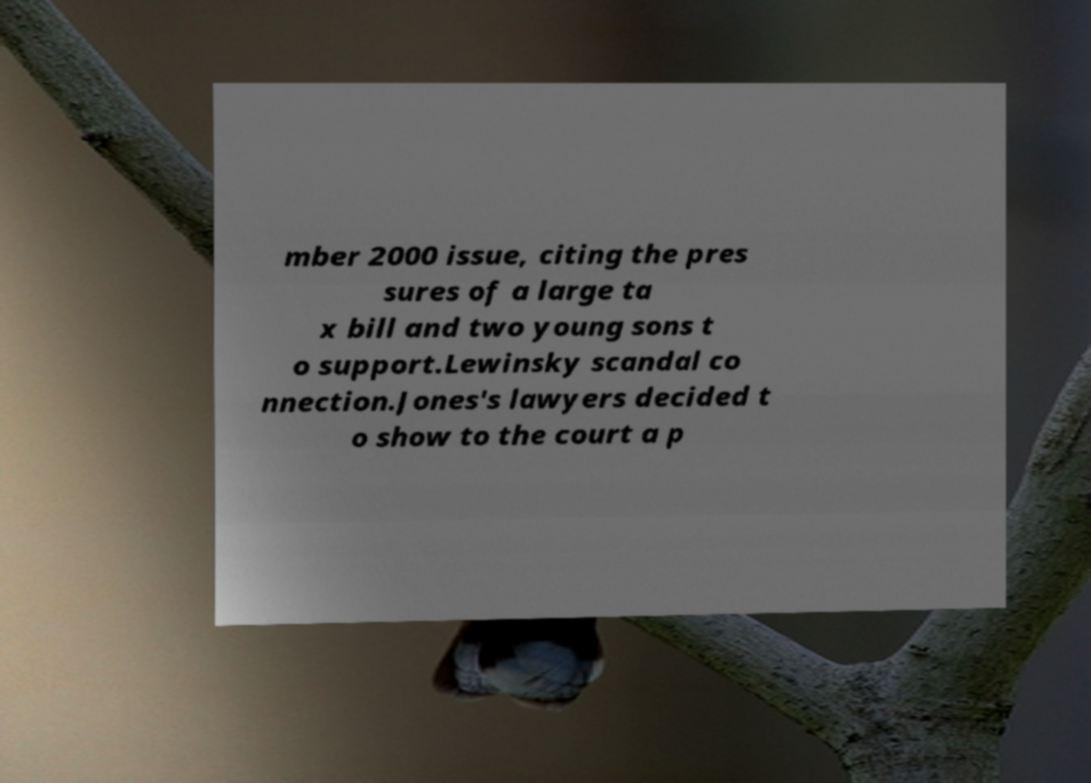Could you extract and type out the text from this image? mber 2000 issue, citing the pres sures of a large ta x bill and two young sons t o support.Lewinsky scandal co nnection.Jones's lawyers decided t o show to the court a p 